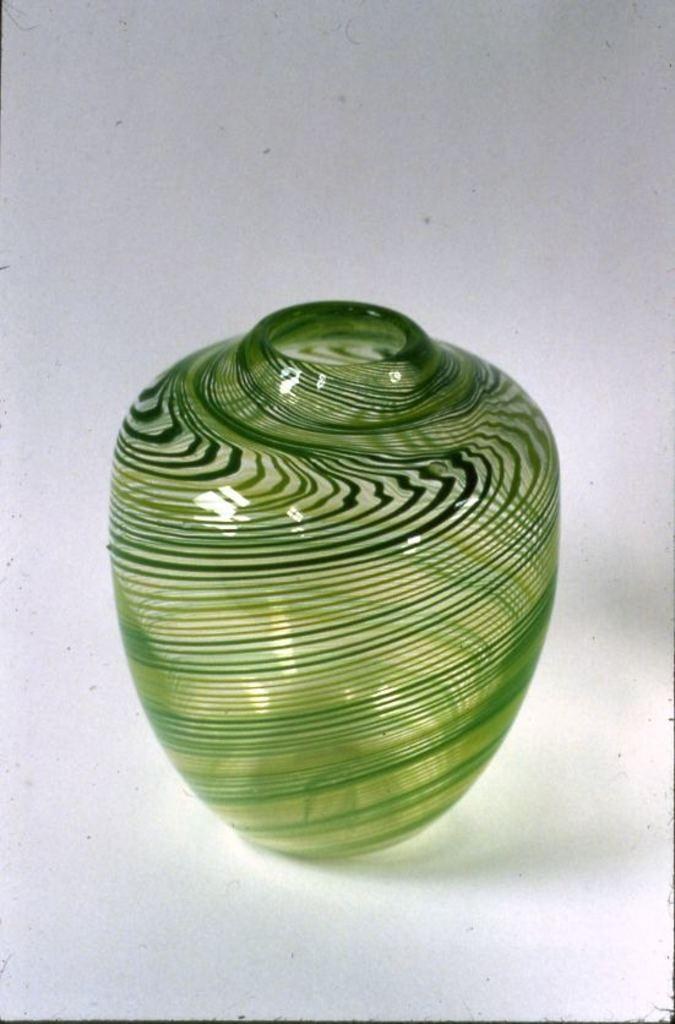What object is present in the image? There is a flower vase in the image. What color is the flower vase? The flower vase is green in color. Are there any patterns or designs on the flower vase? Yes, there are stripes on the flower vase. How many prisoners are visible in the image? There are no prisoners or jail in the image; it features a green flower vase with stripes. What type of thing is moving on the tracks in the image? There are no trains or tracks present in the image; it only shows a green flower vase with stripes. 